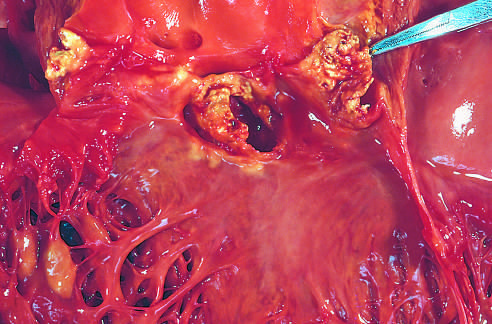what is caused by staphylococcus aureus on a congenitally bicuspid aortic valve with extensive cuspal destruction and ring abscess?
Answer the question using a single word or phrase. Acute endocarditis 